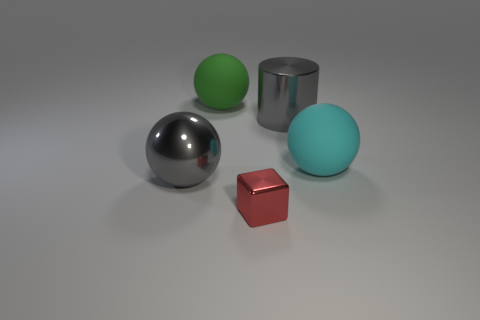Does the large gray object on the left side of the large metal cylinder have the same material as the ball to the right of the large green object?
Offer a very short reply. No. There is a sphere that is made of the same material as the big cyan object; what is its color?
Your response must be concise. Green. How many green rubber balls are the same size as the cyan ball?
Your answer should be very brief. 1. How many other things are the same color as the big cylinder?
Provide a succinct answer. 1. Are there any other things that have the same size as the block?
Your answer should be compact. No. There is a large gray thing in front of the cyan sphere; does it have the same shape as the matte thing left of the large cyan thing?
Offer a very short reply. Yes. What shape is the green rubber object that is the same size as the gray shiny cylinder?
Provide a short and direct response. Sphere. Is the number of tiny red blocks left of the gray sphere the same as the number of big rubber spheres to the left of the small thing?
Give a very brief answer. No. Are there any other things that are the same shape as the tiny metallic object?
Give a very brief answer. No. Are the gray object that is right of the metal ball and the tiny red cube made of the same material?
Your answer should be very brief. Yes. 